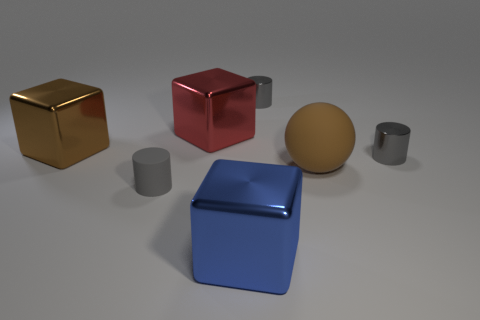The object that is right of the large red shiny thing and in front of the big ball is what color?
Provide a succinct answer. Blue. Are there more small gray rubber cylinders than large brown things?
Make the answer very short. No. Do the small thing that is behind the large brown shiny thing and the tiny gray matte thing have the same shape?
Your answer should be compact. Yes. How many metal objects are big cyan objects or small gray objects?
Ensure brevity in your answer.  2. Are there any red things made of the same material as the brown block?
Your answer should be compact. Yes. What is the material of the large red object?
Offer a very short reply. Metal. What is the shape of the gray thing that is behind the big shiny object that is left of the gray object in front of the sphere?
Provide a succinct answer. Cylinder. Are there more balls that are left of the red block than rubber things?
Offer a very short reply. No. There is a small gray matte object; does it have the same shape as the shiny object that is on the left side of the small gray rubber object?
Make the answer very short. No. The big metallic thing that is the same color as the large rubber thing is what shape?
Keep it short and to the point. Cube. 